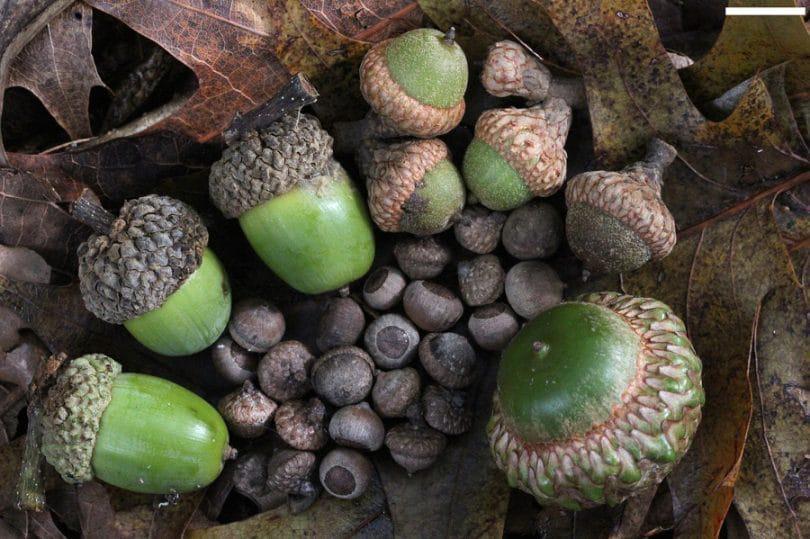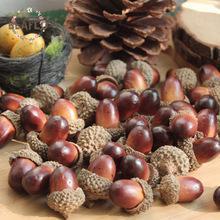The first image is the image on the left, the second image is the image on the right. Evaluate the accuracy of this statement regarding the images: "There are brown and green acorns.". Is it true? Answer yes or no. Yes. 